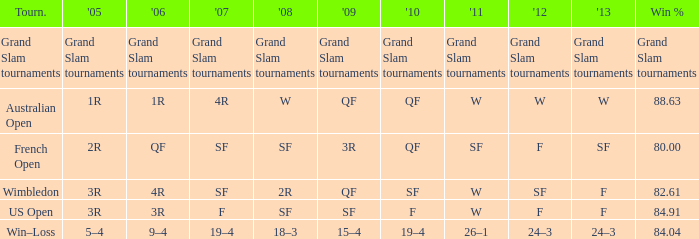What in 2013 has a 2009 of 3r? SF. 